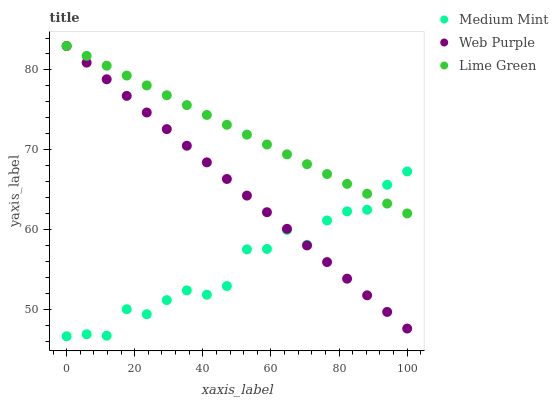Does Medium Mint have the minimum area under the curve?
Answer yes or no. Yes. Does Lime Green have the maximum area under the curve?
Answer yes or no. Yes. Does Web Purple have the minimum area under the curve?
Answer yes or no. No. Does Web Purple have the maximum area under the curve?
Answer yes or no. No. Is Web Purple the smoothest?
Answer yes or no. Yes. Is Medium Mint the roughest?
Answer yes or no. Yes. Is Lime Green the smoothest?
Answer yes or no. No. Is Lime Green the roughest?
Answer yes or no. No. Does Medium Mint have the lowest value?
Answer yes or no. Yes. Does Web Purple have the lowest value?
Answer yes or no. No. Does Lime Green have the highest value?
Answer yes or no. Yes. Does Lime Green intersect Medium Mint?
Answer yes or no. Yes. Is Lime Green less than Medium Mint?
Answer yes or no. No. Is Lime Green greater than Medium Mint?
Answer yes or no. No. 